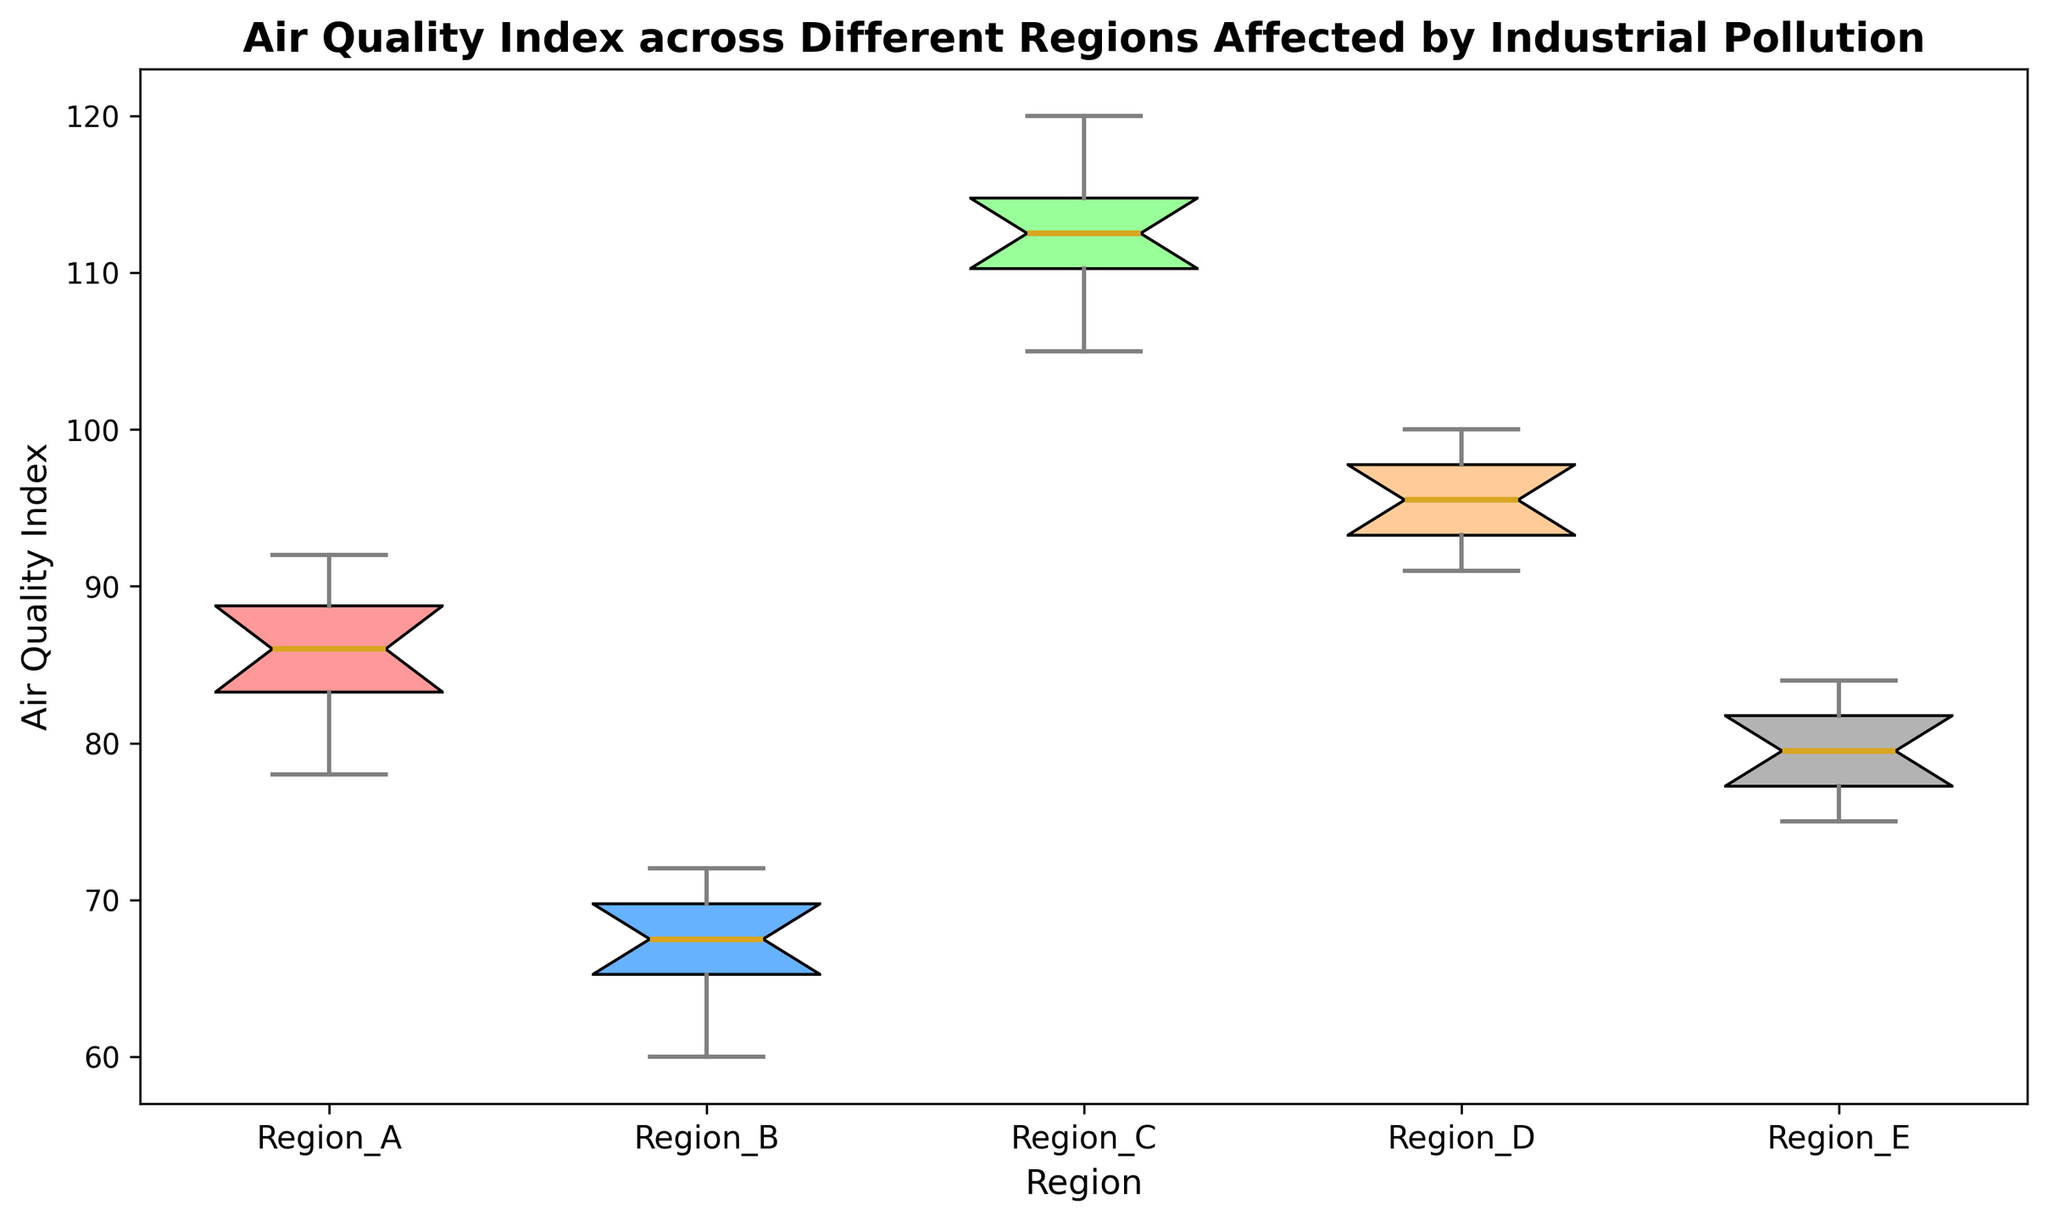What's the median Air Quality Index for Region C? The median is the middle value when the data points are ordered. For Region C, the data points are [105, 109, 110, 111, 112, 113, 114, 115, 117, 120]. The middle values are 112 and 113, so the median is (112 + 113) / 2 = 112.5
Answer: 112.5 Which region has the lowest median Air Quality Index? To find the region with the lowest median, compare the median values of all regions. The medians are Region A: 86, Region B: 68, Region C: 112.5, Region D: 96, Region E: 79. Region B has the lowest median of 68
Answer: Region B How does the interquartile range (IQR) of Region D compare to that of Region A? The IQR is the difference between the third quartile (Q3) and the first quartile (Q1). For Region D, Q3 is approximately 98 and Q1 is approximately 93, so IQR is 98 - 93 = 5. For Region A, Q3 is approximately 89 and Q1 is approximately 83, so IQR is 89 - 83 = 6. Therefore, the IQR of Region D is smaller
Answer: Region D has a smaller IQR Which region has the widest range of Air Quality Index values? The range is the difference between the maximum and minimum values. The ranges are: Region A: 92 - 78 = 14, Region B: 72 - 60 = 12, Region C: 120 - 105 = 15, Region D: 100 - 91 = 9, Region E: 84 - 75 = 9. Region C has the widest range of 15
Answer: Region C What is the color of the box representing Region E? The coloring scheme of the boxes is indicated by different shades. Region E corresponds to the grey-colored box
Answer: grey Between which two regions is the difference in median Air Quality Index the greatest? The regions with the greatest difference are found by comparing the median values. The medians: Region A: 86, Region B: 68, Region C: 112.5, Region D: 96, Region E: 79. The greatest difference is between Region C (112.5) and Region B (68), which is 112.5 - 68 = 44.5
Answer: Region C and Region B Which regions have an Air Quality Index interquartile range (IQR) that is less than 10 points? To find regions with an IQR < 10, calculate IQR for each. Region A: 6, Region B: 4, Region C: 5, Region D: 5, and Region E: 8. All regions have an IQR less than 10
Answer: All regions 